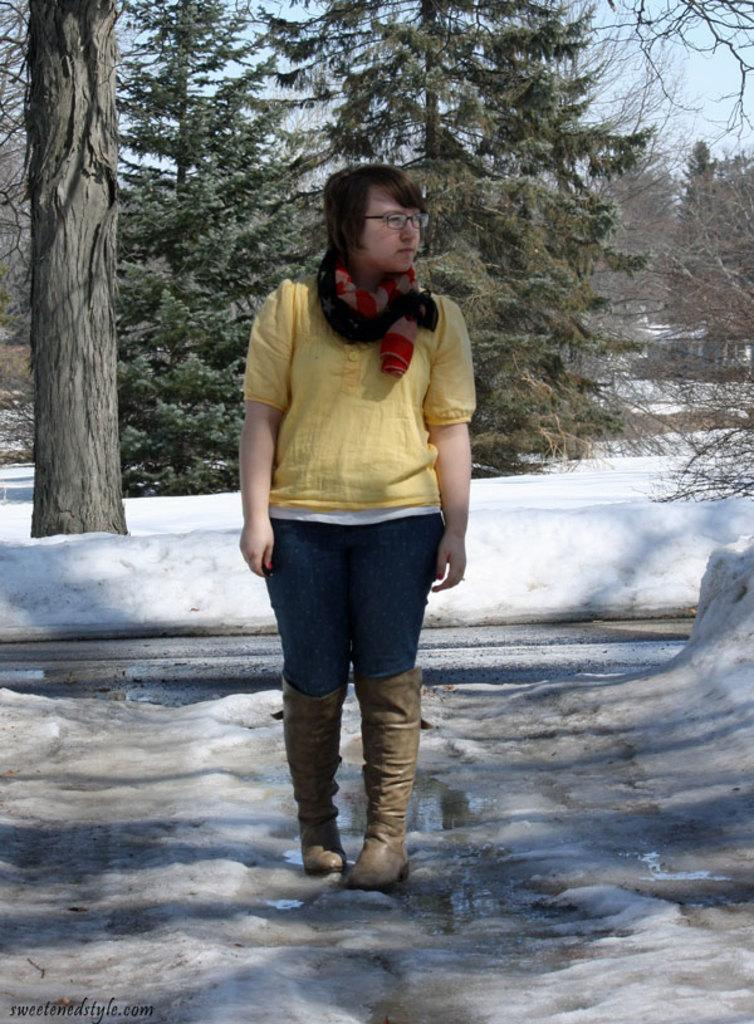Who is present in the image? There is a woman in the image. What is the woman standing on? The woman is standing on the snow. What can be seen in the background of the image? There is sky and trees visible in the background of the image. What is the condition of the ground in the image? The ground appears to be covered in snow. What type of bread is the woman holding in the image? There is no bread present in the image; the woman is standing on the snow with no visible objects in her hands. 